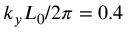<formula> <loc_0><loc_0><loc_500><loc_500>k _ { y } L _ { 0 } / 2 \pi = 0 . 4</formula> 